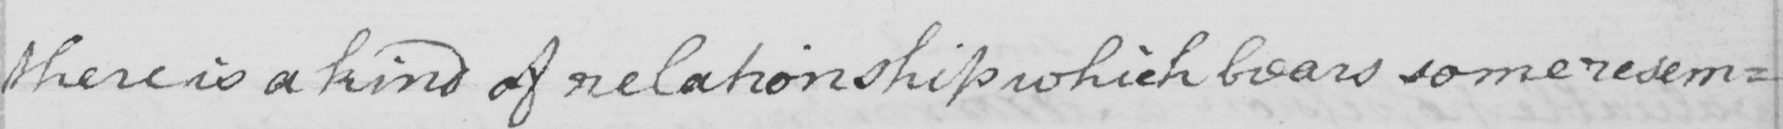Please provide the text content of this handwritten line. there is a kind of relationship which bears some resem= 